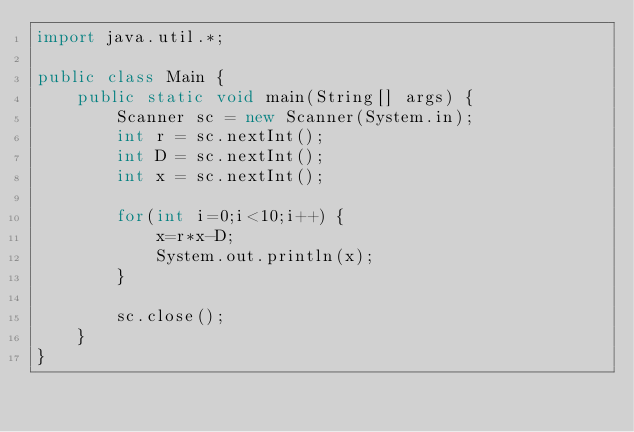Convert code to text. <code><loc_0><loc_0><loc_500><loc_500><_Java_>import java.util.*;

public class Main {
	public static void main(String[] args) {
		Scanner sc = new Scanner(System.in);
		int r = sc.nextInt();
		int D = sc.nextInt();
		int x = sc.nextInt();
		
		for(int i=0;i<10;i++) {
			x=r*x-D;
			System.out.println(x);
		}
		
		sc.close();
	}
}
</code> 